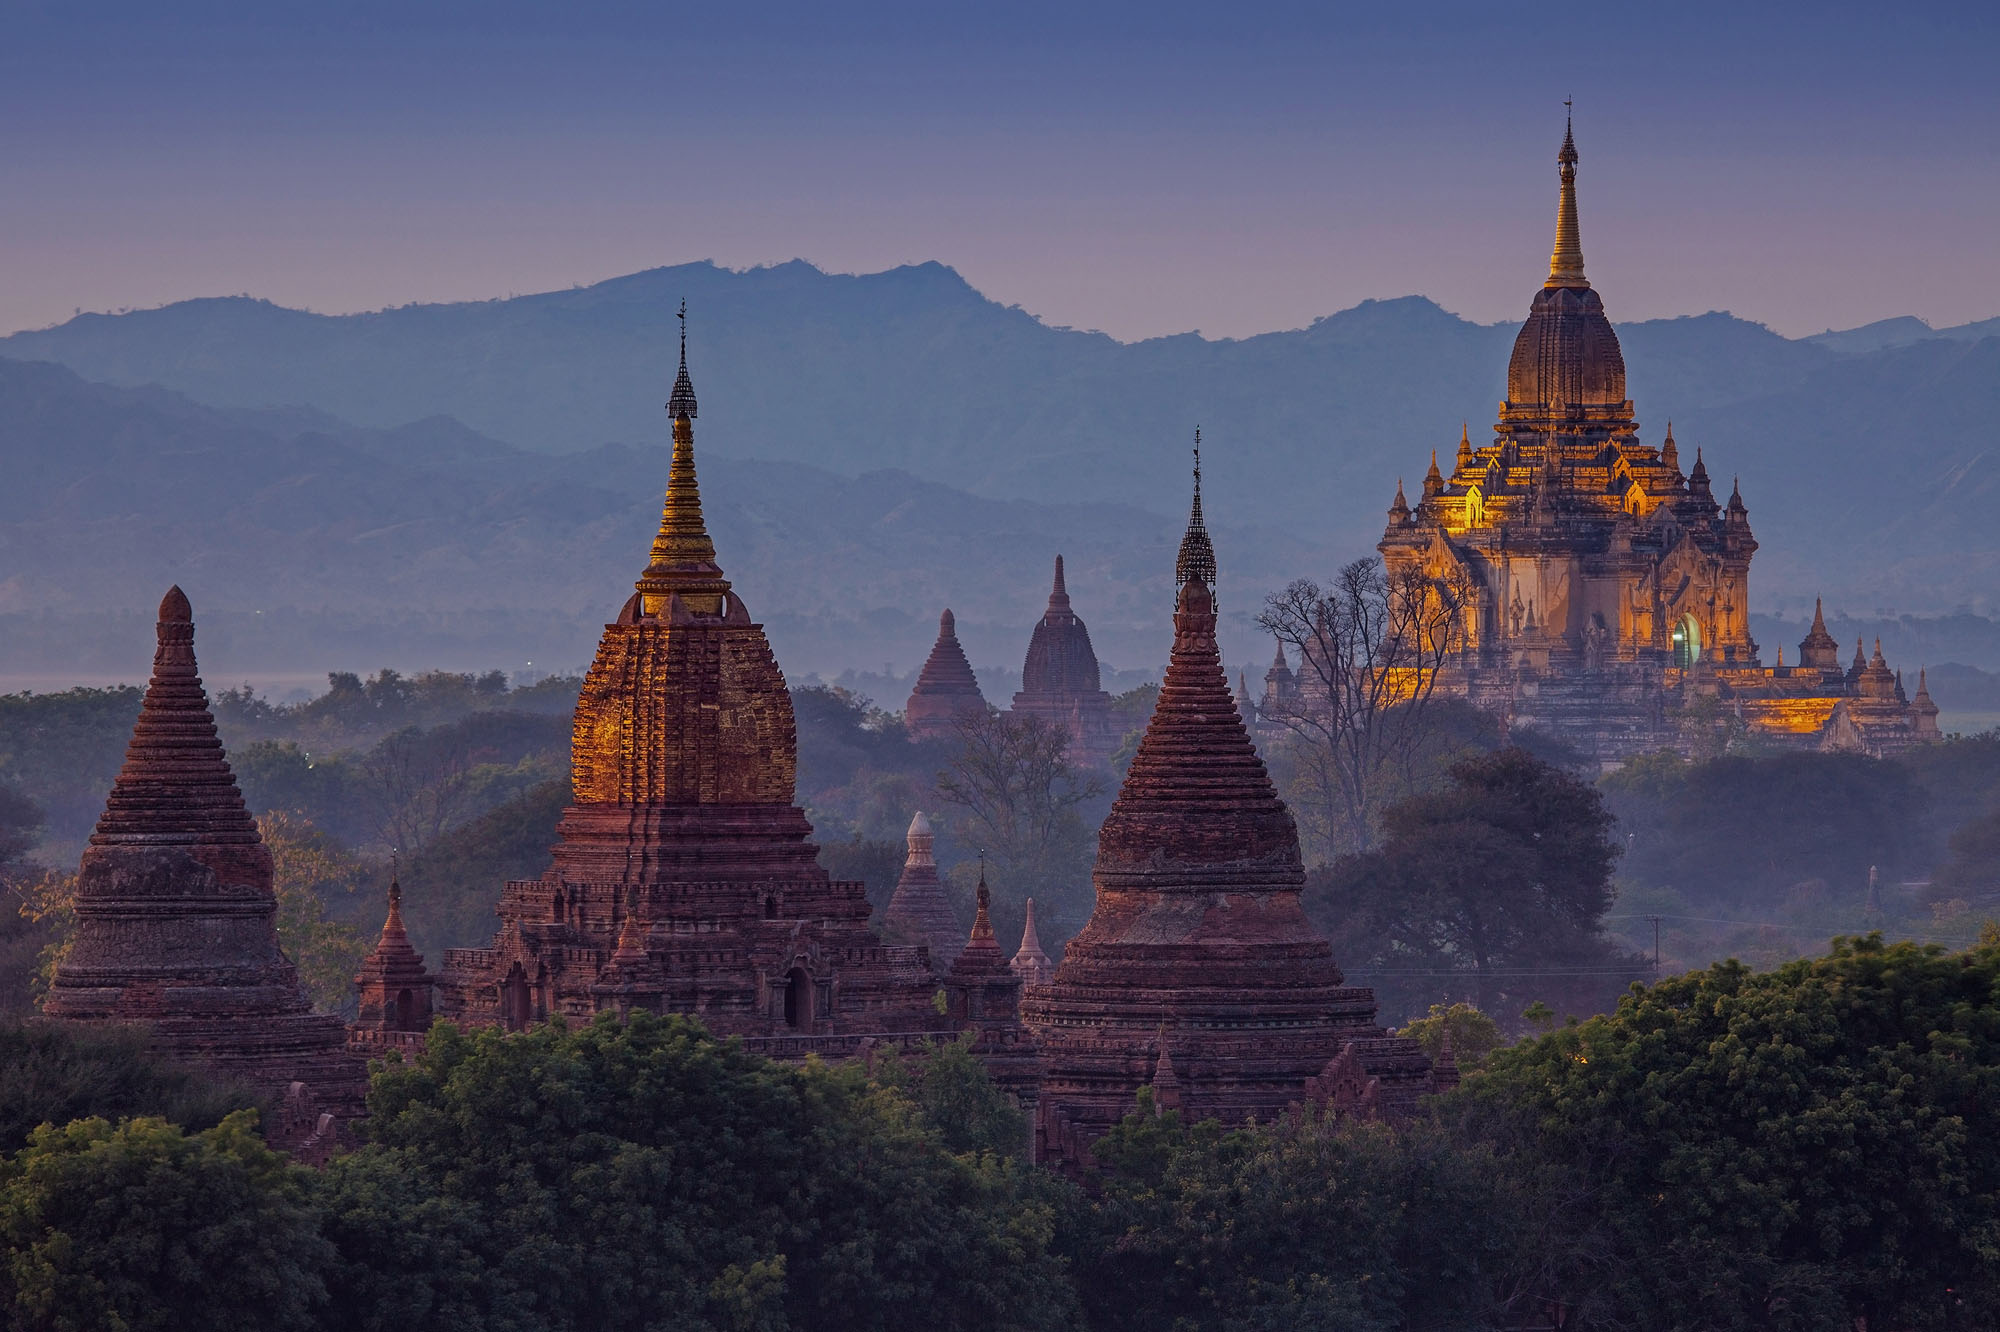Imagine you are a time traveler who just stepped into this scene. Describe your feelings and observations as you explore the area. Stepping into the ancient city of Bagan as a time traveler, I am immediately enveloped by an overwhelming sense of awe and reverence. The first thing that strikes me is the harmonious blend of nature and man-made wonders, where towering pagodas seamlessly integrate with the verdant landscape. The bricks of the temples radiate a warm glow, absorbing and reflecting the rays of the setting sun. I wander through narrow pathways lined with ancient sculptures and intricate carvings that tell tales of myth and legend. The aroma of incense wafts through the air, mingling with the earthy scent of the ground beneath my feet. Pilgrims and monks move serenely, their devotion palpable in their steady gait and meditative expressions. I am acutely aware of the sacredness of this place, a living testament to centuries of faith, artistry, and human spirit. The enchanting beauty, profound history, and spiritual depth of Bagan leave me feeling a deep sense of peace and connectedness to something far greater than myself. 